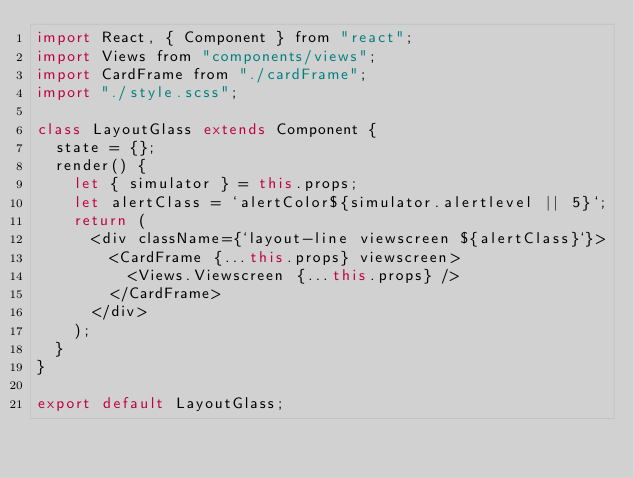<code> <loc_0><loc_0><loc_500><loc_500><_JavaScript_>import React, { Component } from "react";
import Views from "components/views";
import CardFrame from "./cardFrame";
import "./style.scss";

class LayoutGlass extends Component {
  state = {};
  render() {
    let { simulator } = this.props;
    let alertClass = `alertColor${simulator.alertlevel || 5}`;
    return (
      <div className={`layout-line viewscreen ${alertClass}`}>
        <CardFrame {...this.props} viewscreen>
          <Views.Viewscreen {...this.props} />
        </CardFrame>
      </div>
    );
  }
}

export default LayoutGlass;
</code> 